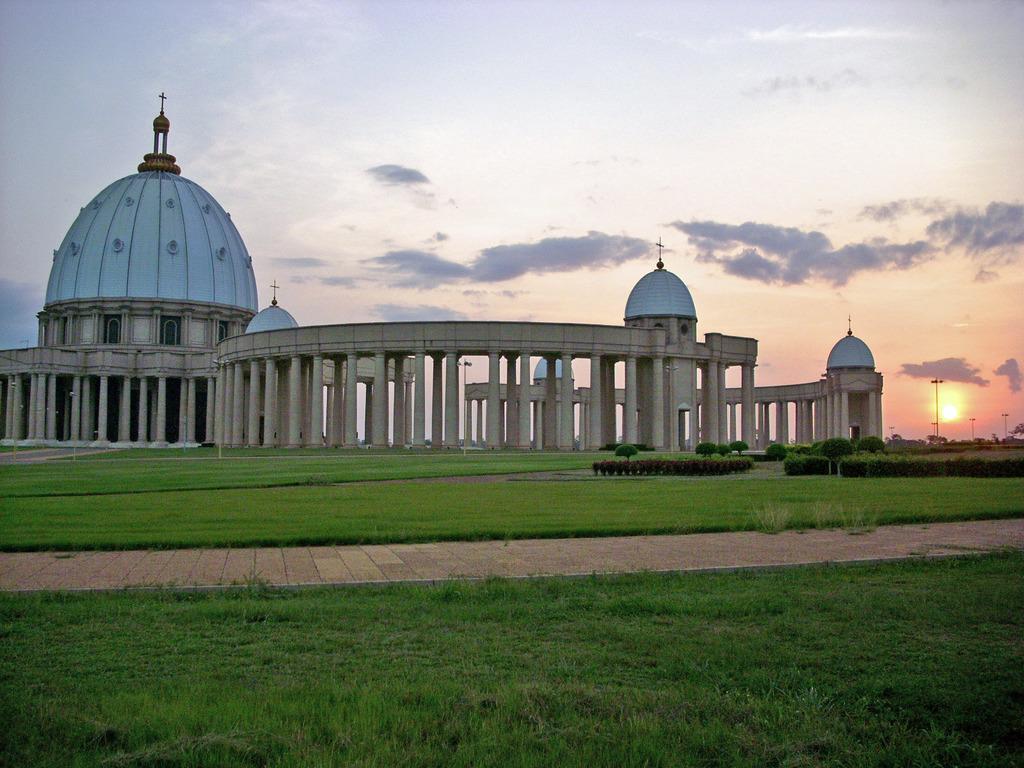Describe this image in one or two sentences. In the foreground of the picture there is pavement and there are shrubs and grass. In the center of the picture there are plants, grass and a cathedral. In the background towards right there are street lights and sun in the sky. At the top it is sky. 